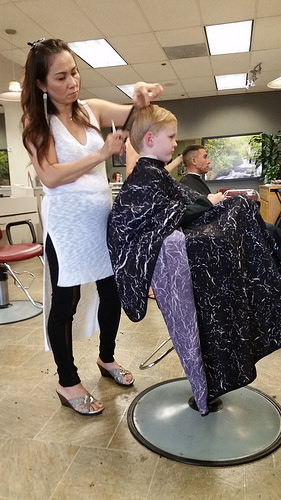<image>
Can you confirm if the breast is on the child head? No. The breast is not positioned on the child head. They may be near each other, but the breast is not supported by or resting on top of the child head. 